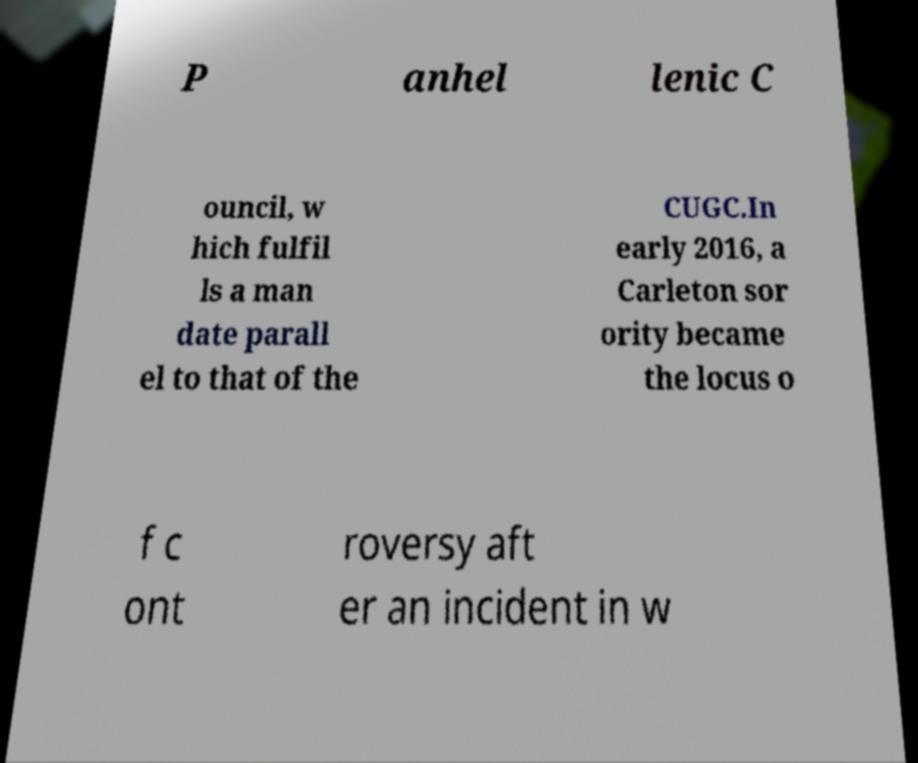Could you extract and type out the text from this image? P anhel lenic C ouncil, w hich fulfil ls a man date parall el to that of the CUGC.In early 2016, a Carleton sor ority became the locus o f c ont roversy aft er an incident in w 